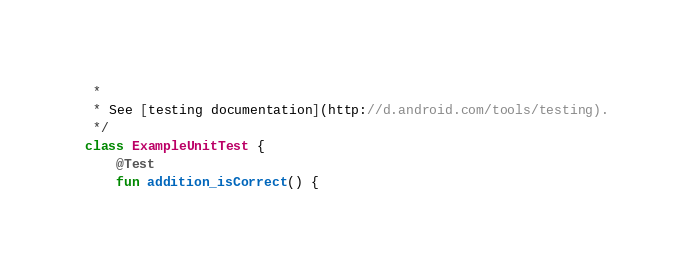<code> <loc_0><loc_0><loc_500><loc_500><_Kotlin_> *
 * See [testing documentation](http://d.android.com/tools/testing).
 */
class ExampleUnitTest {
    @Test
    fun addition_isCorrect() {</code> 